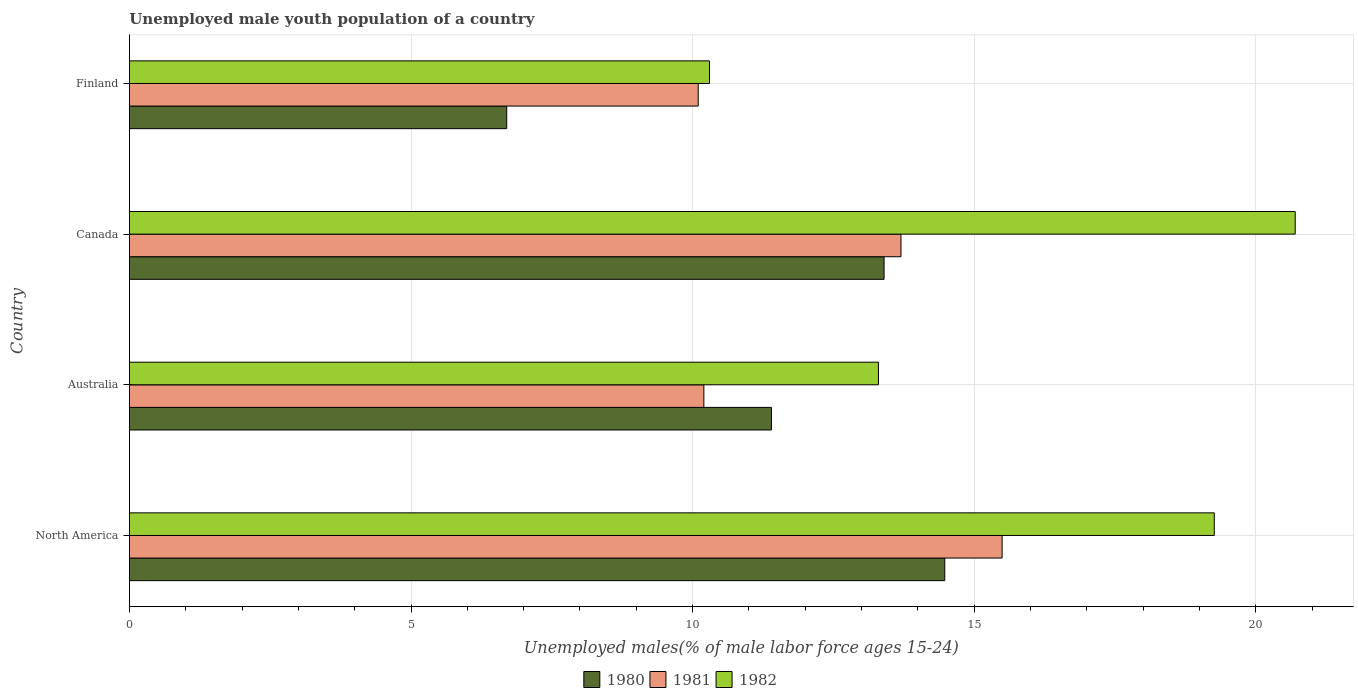In how many cases, is the number of bars for a given country not equal to the number of legend labels?
Provide a short and direct response. 0. What is the percentage of unemployed male youth population in 1981 in Finland?
Give a very brief answer. 10.1. Across all countries, what is the maximum percentage of unemployed male youth population in 1981?
Keep it short and to the point. 15.5. Across all countries, what is the minimum percentage of unemployed male youth population in 1982?
Your answer should be very brief. 10.3. In which country was the percentage of unemployed male youth population in 1981 maximum?
Your answer should be very brief. North America. In which country was the percentage of unemployed male youth population in 1981 minimum?
Provide a succinct answer. Finland. What is the total percentage of unemployed male youth population in 1980 in the graph?
Your response must be concise. 45.98. What is the difference between the percentage of unemployed male youth population in 1982 in Australia and that in North America?
Provide a short and direct response. -5.96. What is the difference between the percentage of unemployed male youth population in 1981 in Canada and the percentage of unemployed male youth population in 1982 in Finland?
Provide a short and direct response. 3.4. What is the average percentage of unemployed male youth population in 1980 per country?
Your response must be concise. 11.49. What is the difference between the percentage of unemployed male youth population in 1980 and percentage of unemployed male youth population in 1981 in Finland?
Your answer should be very brief. -3.4. What is the ratio of the percentage of unemployed male youth population in 1980 in Australia to that in Finland?
Provide a succinct answer. 1.7. What is the difference between the highest and the second highest percentage of unemployed male youth population in 1982?
Offer a very short reply. 1.44. What is the difference between the highest and the lowest percentage of unemployed male youth population in 1981?
Your answer should be compact. 5.4. Is it the case that in every country, the sum of the percentage of unemployed male youth population in 1980 and percentage of unemployed male youth population in 1981 is greater than the percentage of unemployed male youth population in 1982?
Offer a terse response. Yes. How many countries are there in the graph?
Provide a succinct answer. 4. Where does the legend appear in the graph?
Provide a succinct answer. Bottom center. How are the legend labels stacked?
Provide a succinct answer. Horizontal. What is the title of the graph?
Ensure brevity in your answer.  Unemployed male youth population of a country. Does "2004" appear as one of the legend labels in the graph?
Give a very brief answer. No. What is the label or title of the X-axis?
Ensure brevity in your answer.  Unemployed males(% of male labor force ages 15-24). What is the label or title of the Y-axis?
Keep it short and to the point. Country. What is the Unemployed males(% of male labor force ages 15-24) of 1980 in North America?
Offer a terse response. 14.48. What is the Unemployed males(% of male labor force ages 15-24) in 1981 in North America?
Keep it short and to the point. 15.5. What is the Unemployed males(% of male labor force ages 15-24) in 1982 in North America?
Make the answer very short. 19.26. What is the Unemployed males(% of male labor force ages 15-24) in 1980 in Australia?
Ensure brevity in your answer.  11.4. What is the Unemployed males(% of male labor force ages 15-24) of 1981 in Australia?
Your answer should be compact. 10.2. What is the Unemployed males(% of male labor force ages 15-24) in 1982 in Australia?
Ensure brevity in your answer.  13.3. What is the Unemployed males(% of male labor force ages 15-24) of 1980 in Canada?
Offer a very short reply. 13.4. What is the Unemployed males(% of male labor force ages 15-24) in 1981 in Canada?
Ensure brevity in your answer.  13.7. What is the Unemployed males(% of male labor force ages 15-24) in 1982 in Canada?
Provide a succinct answer. 20.7. What is the Unemployed males(% of male labor force ages 15-24) in 1980 in Finland?
Provide a succinct answer. 6.7. What is the Unemployed males(% of male labor force ages 15-24) in 1981 in Finland?
Provide a succinct answer. 10.1. What is the Unemployed males(% of male labor force ages 15-24) of 1982 in Finland?
Give a very brief answer. 10.3. Across all countries, what is the maximum Unemployed males(% of male labor force ages 15-24) of 1980?
Offer a terse response. 14.48. Across all countries, what is the maximum Unemployed males(% of male labor force ages 15-24) in 1981?
Your answer should be very brief. 15.5. Across all countries, what is the maximum Unemployed males(% of male labor force ages 15-24) in 1982?
Make the answer very short. 20.7. Across all countries, what is the minimum Unemployed males(% of male labor force ages 15-24) in 1980?
Offer a terse response. 6.7. Across all countries, what is the minimum Unemployed males(% of male labor force ages 15-24) of 1981?
Provide a short and direct response. 10.1. Across all countries, what is the minimum Unemployed males(% of male labor force ages 15-24) in 1982?
Give a very brief answer. 10.3. What is the total Unemployed males(% of male labor force ages 15-24) in 1980 in the graph?
Give a very brief answer. 45.98. What is the total Unemployed males(% of male labor force ages 15-24) of 1981 in the graph?
Your response must be concise. 49.5. What is the total Unemployed males(% of male labor force ages 15-24) of 1982 in the graph?
Your answer should be very brief. 63.56. What is the difference between the Unemployed males(% of male labor force ages 15-24) in 1980 in North America and that in Australia?
Offer a very short reply. 3.08. What is the difference between the Unemployed males(% of male labor force ages 15-24) of 1981 in North America and that in Australia?
Your answer should be very brief. 5.3. What is the difference between the Unemployed males(% of male labor force ages 15-24) in 1982 in North America and that in Australia?
Offer a terse response. 5.96. What is the difference between the Unemployed males(% of male labor force ages 15-24) of 1980 in North America and that in Canada?
Your answer should be very brief. 1.08. What is the difference between the Unemployed males(% of male labor force ages 15-24) in 1981 in North America and that in Canada?
Provide a short and direct response. 1.8. What is the difference between the Unemployed males(% of male labor force ages 15-24) of 1982 in North America and that in Canada?
Your answer should be compact. -1.44. What is the difference between the Unemployed males(% of male labor force ages 15-24) in 1980 in North America and that in Finland?
Ensure brevity in your answer.  7.78. What is the difference between the Unemployed males(% of male labor force ages 15-24) in 1981 in North America and that in Finland?
Provide a short and direct response. 5.4. What is the difference between the Unemployed males(% of male labor force ages 15-24) in 1982 in North America and that in Finland?
Keep it short and to the point. 8.96. What is the difference between the Unemployed males(% of male labor force ages 15-24) of 1981 in Australia and that in Canada?
Your answer should be compact. -3.5. What is the difference between the Unemployed males(% of male labor force ages 15-24) of 1982 in Australia and that in Canada?
Offer a terse response. -7.4. What is the difference between the Unemployed males(% of male labor force ages 15-24) in 1980 in Canada and that in Finland?
Your answer should be very brief. 6.7. What is the difference between the Unemployed males(% of male labor force ages 15-24) of 1980 in North America and the Unemployed males(% of male labor force ages 15-24) of 1981 in Australia?
Ensure brevity in your answer.  4.28. What is the difference between the Unemployed males(% of male labor force ages 15-24) in 1980 in North America and the Unemployed males(% of male labor force ages 15-24) in 1982 in Australia?
Your answer should be compact. 1.18. What is the difference between the Unemployed males(% of male labor force ages 15-24) in 1981 in North America and the Unemployed males(% of male labor force ages 15-24) in 1982 in Australia?
Your answer should be very brief. 2.2. What is the difference between the Unemployed males(% of male labor force ages 15-24) of 1980 in North America and the Unemployed males(% of male labor force ages 15-24) of 1981 in Canada?
Make the answer very short. 0.78. What is the difference between the Unemployed males(% of male labor force ages 15-24) of 1980 in North America and the Unemployed males(% of male labor force ages 15-24) of 1982 in Canada?
Provide a succinct answer. -6.22. What is the difference between the Unemployed males(% of male labor force ages 15-24) of 1981 in North America and the Unemployed males(% of male labor force ages 15-24) of 1982 in Canada?
Make the answer very short. -5.2. What is the difference between the Unemployed males(% of male labor force ages 15-24) in 1980 in North America and the Unemployed males(% of male labor force ages 15-24) in 1981 in Finland?
Keep it short and to the point. 4.38. What is the difference between the Unemployed males(% of male labor force ages 15-24) in 1980 in North America and the Unemployed males(% of male labor force ages 15-24) in 1982 in Finland?
Keep it short and to the point. 4.18. What is the difference between the Unemployed males(% of male labor force ages 15-24) of 1981 in North America and the Unemployed males(% of male labor force ages 15-24) of 1982 in Finland?
Keep it short and to the point. 5.2. What is the difference between the Unemployed males(% of male labor force ages 15-24) in 1980 in Australia and the Unemployed males(% of male labor force ages 15-24) in 1981 in Canada?
Give a very brief answer. -2.3. What is the difference between the Unemployed males(% of male labor force ages 15-24) in 1980 in Australia and the Unemployed males(% of male labor force ages 15-24) in 1982 in Canada?
Provide a succinct answer. -9.3. What is the difference between the Unemployed males(% of male labor force ages 15-24) of 1981 in Australia and the Unemployed males(% of male labor force ages 15-24) of 1982 in Canada?
Provide a short and direct response. -10.5. What is the difference between the Unemployed males(% of male labor force ages 15-24) of 1980 in Australia and the Unemployed males(% of male labor force ages 15-24) of 1981 in Finland?
Keep it short and to the point. 1.3. What is the difference between the Unemployed males(% of male labor force ages 15-24) of 1980 in Australia and the Unemployed males(% of male labor force ages 15-24) of 1982 in Finland?
Provide a succinct answer. 1.1. What is the difference between the Unemployed males(% of male labor force ages 15-24) of 1981 in Australia and the Unemployed males(% of male labor force ages 15-24) of 1982 in Finland?
Ensure brevity in your answer.  -0.1. What is the difference between the Unemployed males(% of male labor force ages 15-24) of 1980 in Canada and the Unemployed males(% of male labor force ages 15-24) of 1981 in Finland?
Your answer should be compact. 3.3. What is the difference between the Unemployed males(% of male labor force ages 15-24) of 1981 in Canada and the Unemployed males(% of male labor force ages 15-24) of 1982 in Finland?
Keep it short and to the point. 3.4. What is the average Unemployed males(% of male labor force ages 15-24) in 1980 per country?
Your answer should be compact. 11.49. What is the average Unemployed males(% of male labor force ages 15-24) of 1981 per country?
Provide a succinct answer. 12.37. What is the average Unemployed males(% of male labor force ages 15-24) in 1982 per country?
Keep it short and to the point. 15.89. What is the difference between the Unemployed males(% of male labor force ages 15-24) of 1980 and Unemployed males(% of male labor force ages 15-24) of 1981 in North America?
Provide a succinct answer. -1.02. What is the difference between the Unemployed males(% of male labor force ages 15-24) of 1980 and Unemployed males(% of male labor force ages 15-24) of 1982 in North America?
Your answer should be compact. -4.79. What is the difference between the Unemployed males(% of male labor force ages 15-24) of 1981 and Unemployed males(% of male labor force ages 15-24) of 1982 in North America?
Your answer should be very brief. -3.77. What is the difference between the Unemployed males(% of male labor force ages 15-24) in 1980 and Unemployed males(% of male labor force ages 15-24) in 1982 in Australia?
Offer a terse response. -1.9. What is the difference between the Unemployed males(% of male labor force ages 15-24) of 1981 and Unemployed males(% of male labor force ages 15-24) of 1982 in Australia?
Your response must be concise. -3.1. What is the difference between the Unemployed males(% of male labor force ages 15-24) of 1980 and Unemployed males(% of male labor force ages 15-24) of 1981 in Canada?
Provide a succinct answer. -0.3. What is the difference between the Unemployed males(% of male labor force ages 15-24) in 1980 and Unemployed males(% of male labor force ages 15-24) in 1981 in Finland?
Offer a terse response. -3.4. What is the difference between the Unemployed males(% of male labor force ages 15-24) in 1980 and Unemployed males(% of male labor force ages 15-24) in 1982 in Finland?
Give a very brief answer. -3.6. What is the ratio of the Unemployed males(% of male labor force ages 15-24) of 1980 in North America to that in Australia?
Provide a short and direct response. 1.27. What is the ratio of the Unemployed males(% of male labor force ages 15-24) of 1981 in North America to that in Australia?
Give a very brief answer. 1.52. What is the ratio of the Unemployed males(% of male labor force ages 15-24) in 1982 in North America to that in Australia?
Your answer should be very brief. 1.45. What is the ratio of the Unemployed males(% of male labor force ages 15-24) in 1980 in North America to that in Canada?
Your response must be concise. 1.08. What is the ratio of the Unemployed males(% of male labor force ages 15-24) of 1981 in North America to that in Canada?
Your response must be concise. 1.13. What is the ratio of the Unemployed males(% of male labor force ages 15-24) in 1982 in North America to that in Canada?
Offer a terse response. 0.93. What is the ratio of the Unemployed males(% of male labor force ages 15-24) in 1980 in North America to that in Finland?
Keep it short and to the point. 2.16. What is the ratio of the Unemployed males(% of male labor force ages 15-24) in 1981 in North America to that in Finland?
Provide a short and direct response. 1.53. What is the ratio of the Unemployed males(% of male labor force ages 15-24) in 1982 in North America to that in Finland?
Keep it short and to the point. 1.87. What is the ratio of the Unemployed males(% of male labor force ages 15-24) of 1980 in Australia to that in Canada?
Your response must be concise. 0.85. What is the ratio of the Unemployed males(% of male labor force ages 15-24) of 1981 in Australia to that in Canada?
Give a very brief answer. 0.74. What is the ratio of the Unemployed males(% of male labor force ages 15-24) in 1982 in Australia to that in Canada?
Your response must be concise. 0.64. What is the ratio of the Unemployed males(% of male labor force ages 15-24) of 1980 in Australia to that in Finland?
Your answer should be very brief. 1.7. What is the ratio of the Unemployed males(% of male labor force ages 15-24) in 1981 in Australia to that in Finland?
Make the answer very short. 1.01. What is the ratio of the Unemployed males(% of male labor force ages 15-24) in 1982 in Australia to that in Finland?
Make the answer very short. 1.29. What is the ratio of the Unemployed males(% of male labor force ages 15-24) in 1980 in Canada to that in Finland?
Keep it short and to the point. 2. What is the ratio of the Unemployed males(% of male labor force ages 15-24) of 1981 in Canada to that in Finland?
Give a very brief answer. 1.36. What is the ratio of the Unemployed males(% of male labor force ages 15-24) of 1982 in Canada to that in Finland?
Ensure brevity in your answer.  2.01. What is the difference between the highest and the second highest Unemployed males(% of male labor force ages 15-24) in 1980?
Offer a terse response. 1.08. What is the difference between the highest and the second highest Unemployed males(% of male labor force ages 15-24) in 1981?
Offer a terse response. 1.8. What is the difference between the highest and the second highest Unemployed males(% of male labor force ages 15-24) of 1982?
Offer a very short reply. 1.44. What is the difference between the highest and the lowest Unemployed males(% of male labor force ages 15-24) in 1980?
Your response must be concise. 7.78. What is the difference between the highest and the lowest Unemployed males(% of male labor force ages 15-24) in 1981?
Ensure brevity in your answer.  5.4. What is the difference between the highest and the lowest Unemployed males(% of male labor force ages 15-24) in 1982?
Ensure brevity in your answer.  10.4. 